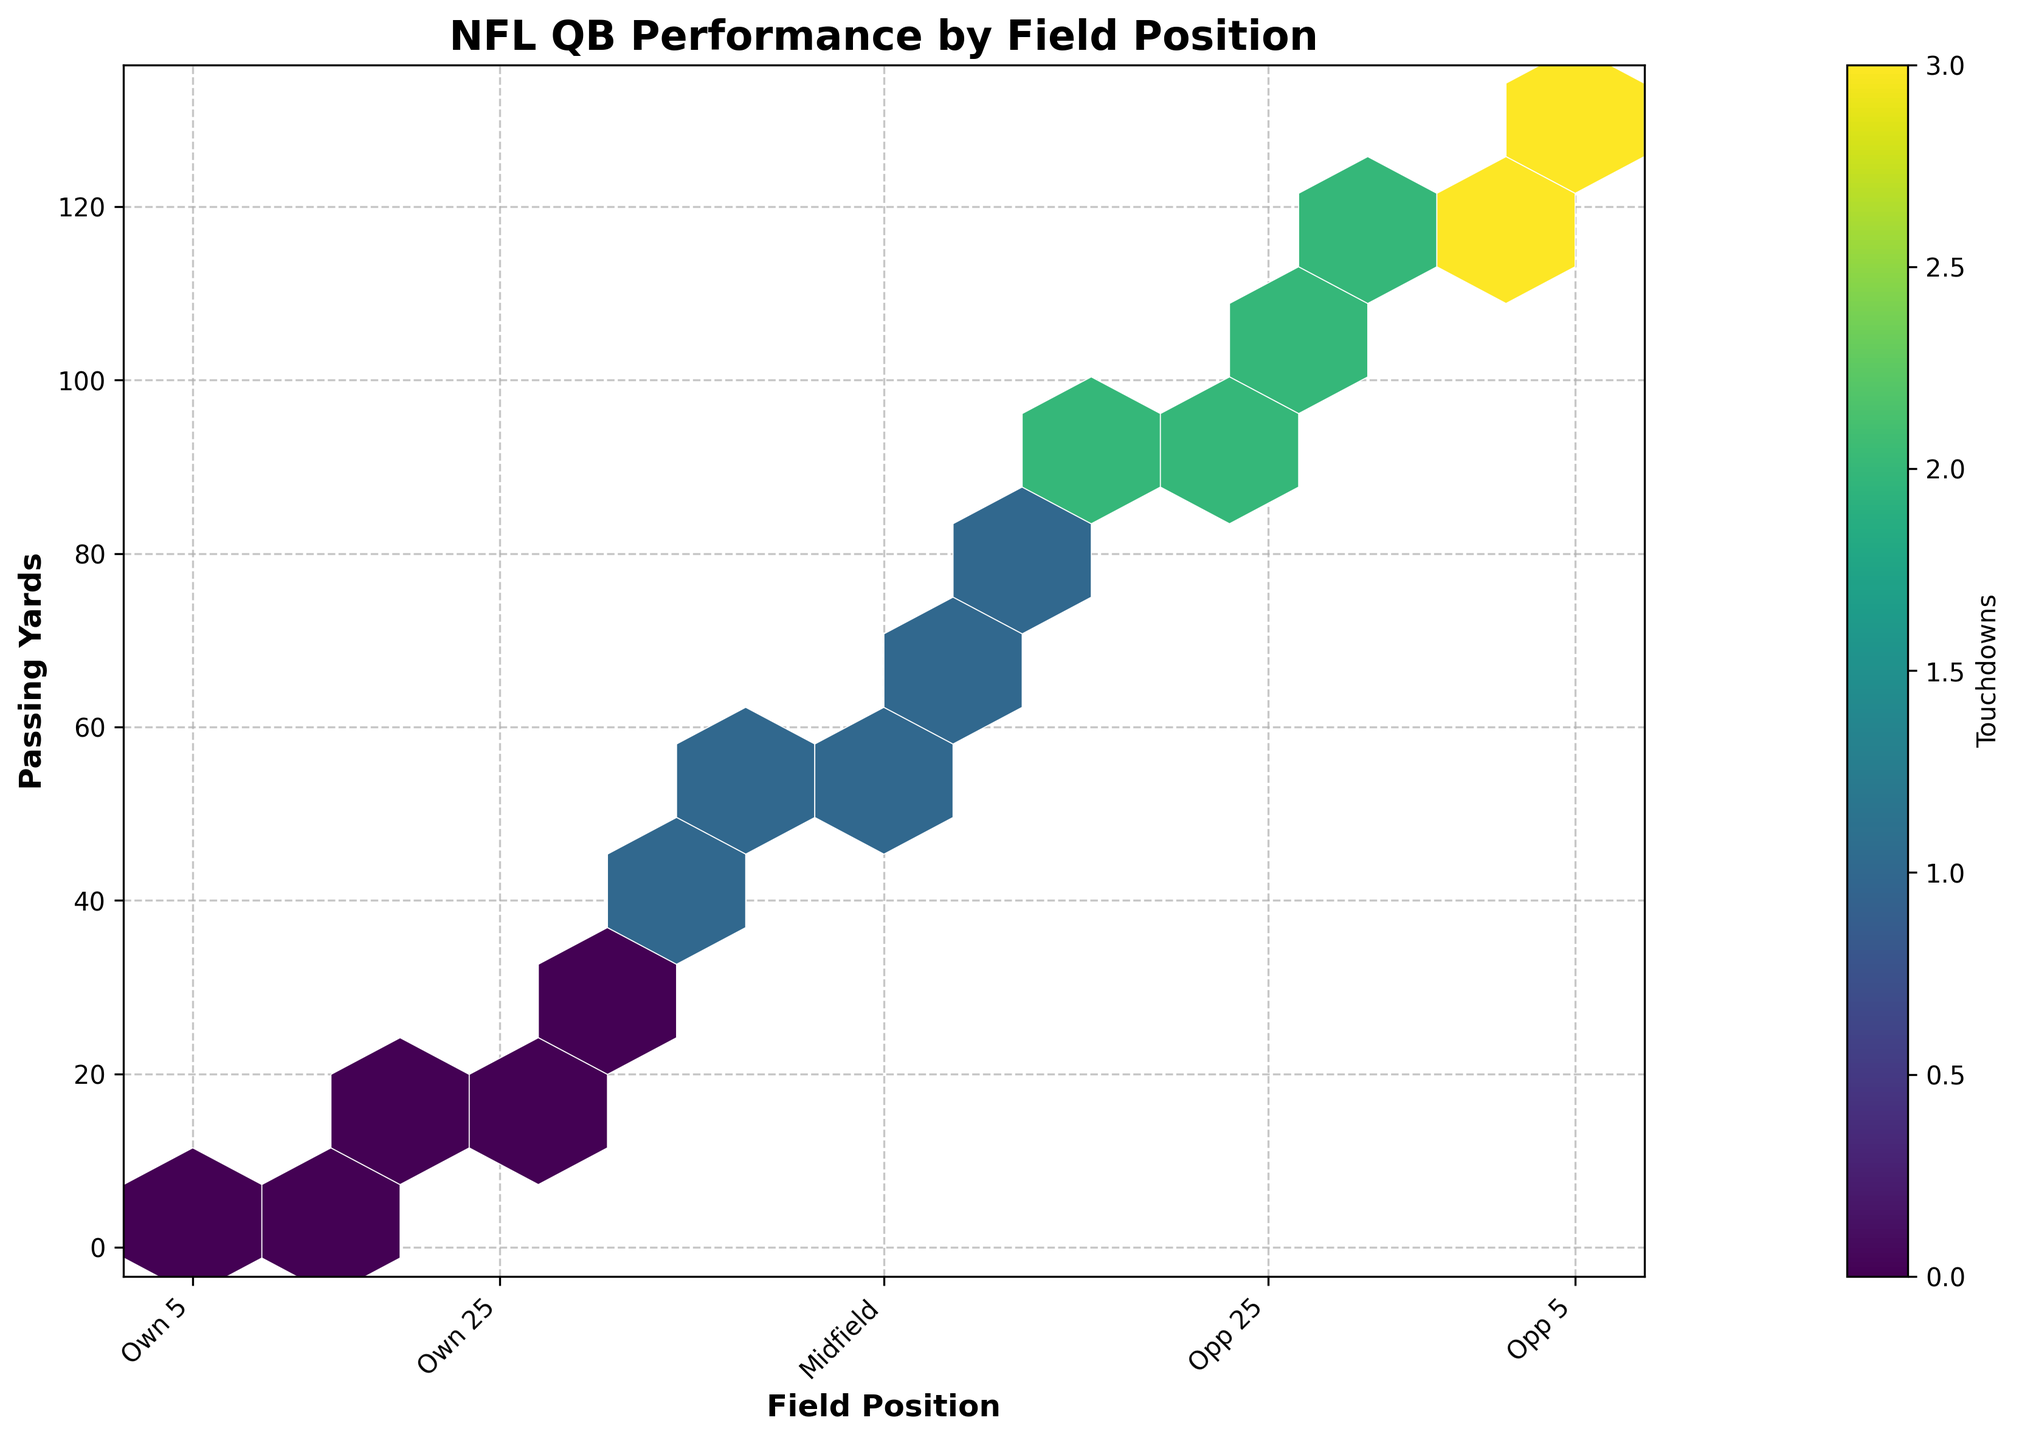What is the title of the hexbin plot? The plot's title is typically displayed at the top and clearly indicates what the plot represents. In this case, it indicates the performance of NFL quarterbacks by field position.
Answer: NFL QB Performance by Field Position What do the x-axis labels represent? The x-axis labels represent different field positions on the football field, ranging from the team's own 5-yard line to the opponent's 5-yard line, with midfield as a center point.
Answer: Field positions How are touchdowns represented in the hexbin plot? Touchdowns are represented by the color intensity within the hexbin cells. The colorbar shows that more intense colors correspond to a higher number of touchdowns.
Answer: Color intensity Which field position accounts for the highest number of touches based on color intensity? You'll observe the most intense color in the cell corresponding to the 'Opp_5' field position on the x-axis, indicating this cell has the highest touchdown count.
Answer: Opp 5 What range of passing yards shows the most density across different field positions? The hexbin plot clusters become denser and more colorful between 50 to 130 passing yards across almost all field positions, indicating high density in this passing yard range.
Answer: 50 to 130 passing yards Comparing the 'Own_5' and 'Opp_5' positions, where do quarterbacks achieve more passing yards? On the plot, there's a higher clustering of hexagons with bright colors (representing touchdowns) near the 'Opp_5' field position and the passing yards axis indicating more passing yards.
Answer: Opp 5 What can you infer about the passing yards when the field position is 'Midfield'? By observing the color intensity and clustering of hexagons around midfield, you can infer that passing yards typically range between 60 and 65 yards, with relatively fewer touchdowns.
Answer: 60 to 65 yards What is the data point with the maximum y-value and what field position does it correspond to? The highest y-value corresponds to the maximum passing yards, which is around 130 yards, observed at the 'Opp_5' position by following along the y-axis.
Answer: Opp_5 Is there a correlation between closer field position to the end zone and the number of passing yards? By observing the distribution of hexagons from 'Own' to 'Opp', you can see that as the field positions get closer to the opponent’s end zone, the number of passing yards also tends to increase.
Answer: Yes How does passing yardage at 'Own_25' compare to 'Opp_35'? For 'Own_25,' passing yardage typically ranges between 18 and 25 yards, whereas 'Opp_35' shows passing yards between 85 and 100, implying more passing yards at 'Opp_35'.
Answer: More at 'Opp_35' 